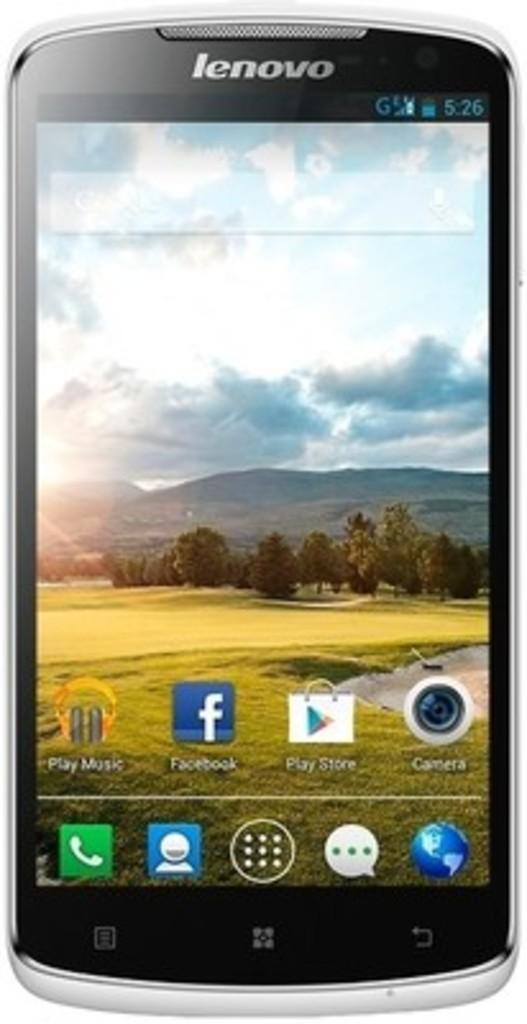<image>
Create a compact narrative representing the image presented. A Lenovo phone has its home screen up with Facebook and the Play Store shown. 